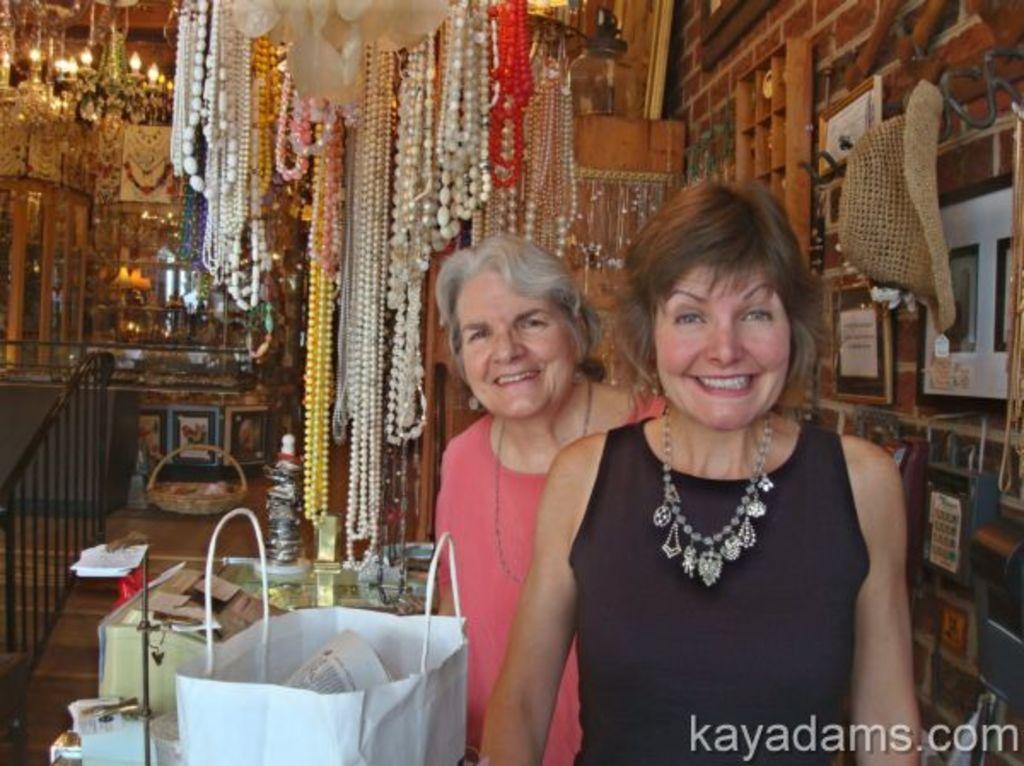How would you summarize this image in a sentence or two? In this image we can see two persons, there are necklaces, some of them are on the wall, there are lights, chandeliers, there is a railing, there are some other objects on the racks, there are some object in the bags, there are boxes, there are photo frames on the wall, also we can see posters, and text on the image. 